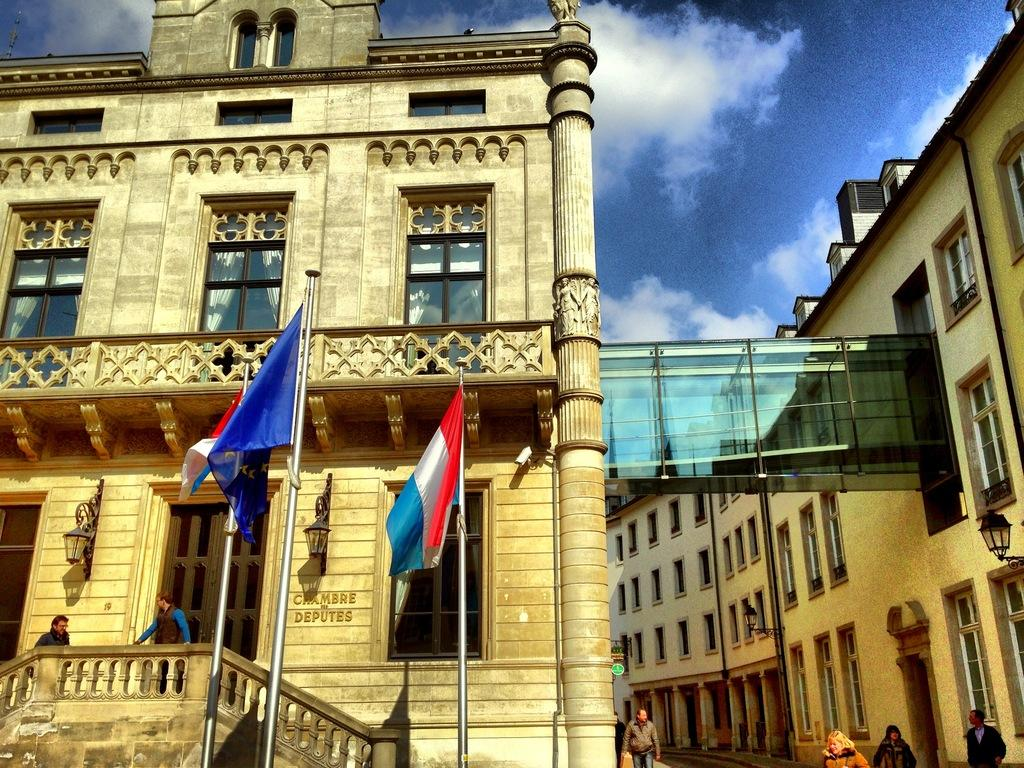What type of structures can be seen in the image? There are buildings in the image. What is located in the middle of the image? There are flags and lights in the middle of the image. What is visible at the top of the image? The sky is visible at the top of the image. Who or what can be seen at the bottom of the image? There are persons at the bottom of the image. Can you tell me how many bulbs are illuminated in the image? There is no mention of bulbs in the image; the lights mentioned are likely flags or other illuminated objects. Is there a band playing music in the image? There is no indication of a band or any musical performance in the image. 